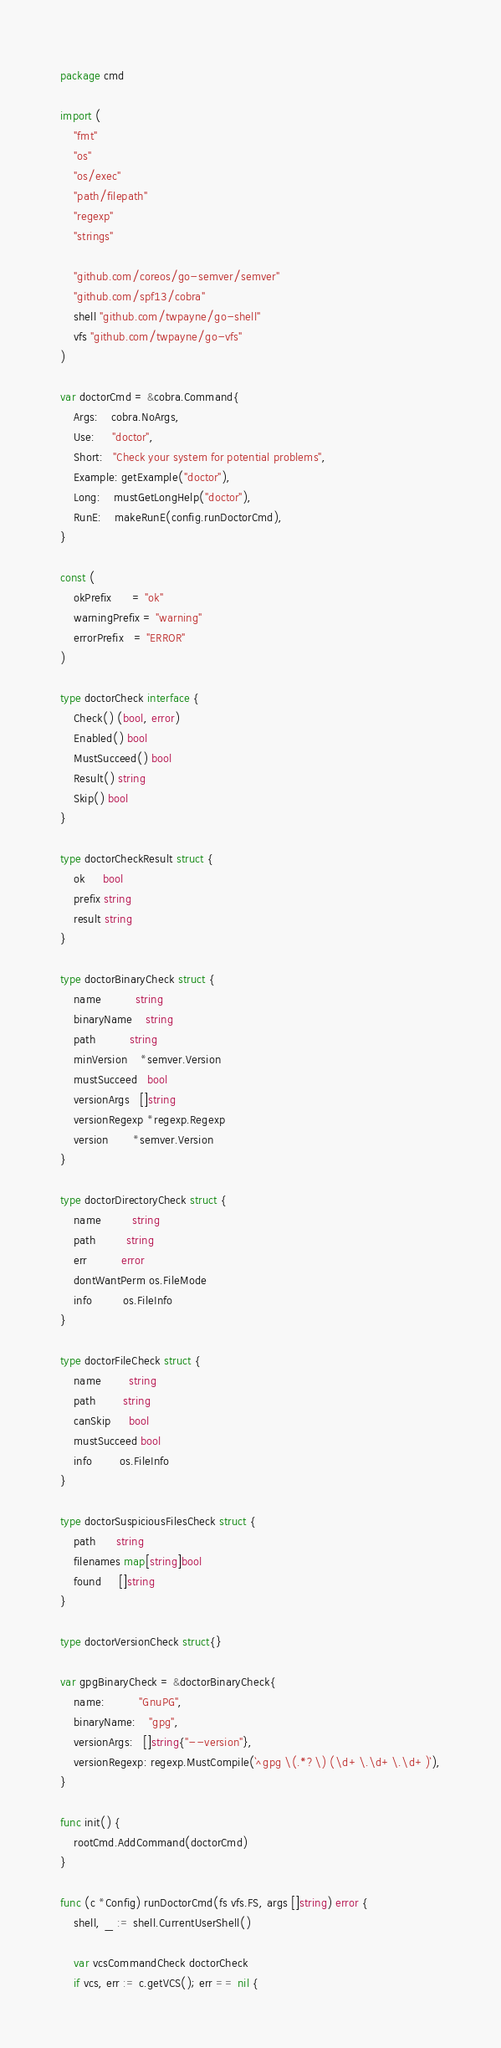<code> <loc_0><loc_0><loc_500><loc_500><_Go_>package cmd

import (
	"fmt"
	"os"
	"os/exec"
	"path/filepath"
	"regexp"
	"strings"

	"github.com/coreos/go-semver/semver"
	"github.com/spf13/cobra"
	shell "github.com/twpayne/go-shell"
	vfs "github.com/twpayne/go-vfs"
)

var doctorCmd = &cobra.Command{
	Args:    cobra.NoArgs,
	Use:     "doctor",
	Short:   "Check your system for potential problems",
	Example: getExample("doctor"),
	Long:    mustGetLongHelp("doctor"),
	RunE:    makeRunE(config.runDoctorCmd),
}

const (
	okPrefix      = "ok"
	warningPrefix = "warning"
	errorPrefix   = "ERROR"
)

type doctorCheck interface {
	Check() (bool, error)
	Enabled() bool
	MustSucceed() bool
	Result() string
	Skip() bool
}

type doctorCheckResult struct {
	ok     bool
	prefix string
	result string
}

type doctorBinaryCheck struct {
	name          string
	binaryName    string
	path          string
	minVersion    *semver.Version
	mustSucceed   bool
	versionArgs   []string
	versionRegexp *regexp.Regexp
	version       *semver.Version
}

type doctorDirectoryCheck struct {
	name         string
	path         string
	err          error
	dontWantPerm os.FileMode
	info         os.FileInfo
}

type doctorFileCheck struct {
	name        string
	path        string
	canSkip     bool
	mustSucceed bool
	info        os.FileInfo
}

type doctorSuspiciousFilesCheck struct {
	path      string
	filenames map[string]bool
	found     []string
}

type doctorVersionCheck struct{}

var gpgBinaryCheck = &doctorBinaryCheck{
	name:          "GnuPG",
	binaryName:    "gpg",
	versionArgs:   []string{"--version"},
	versionRegexp: regexp.MustCompile(`^gpg \(.*?\) (\d+\.\d+\.\d+)`),
}

func init() {
	rootCmd.AddCommand(doctorCmd)
}

func (c *Config) runDoctorCmd(fs vfs.FS, args []string) error {
	shell, _ := shell.CurrentUserShell()

	var vcsCommandCheck doctorCheck
	if vcs, err := c.getVCS(); err == nil {</code> 